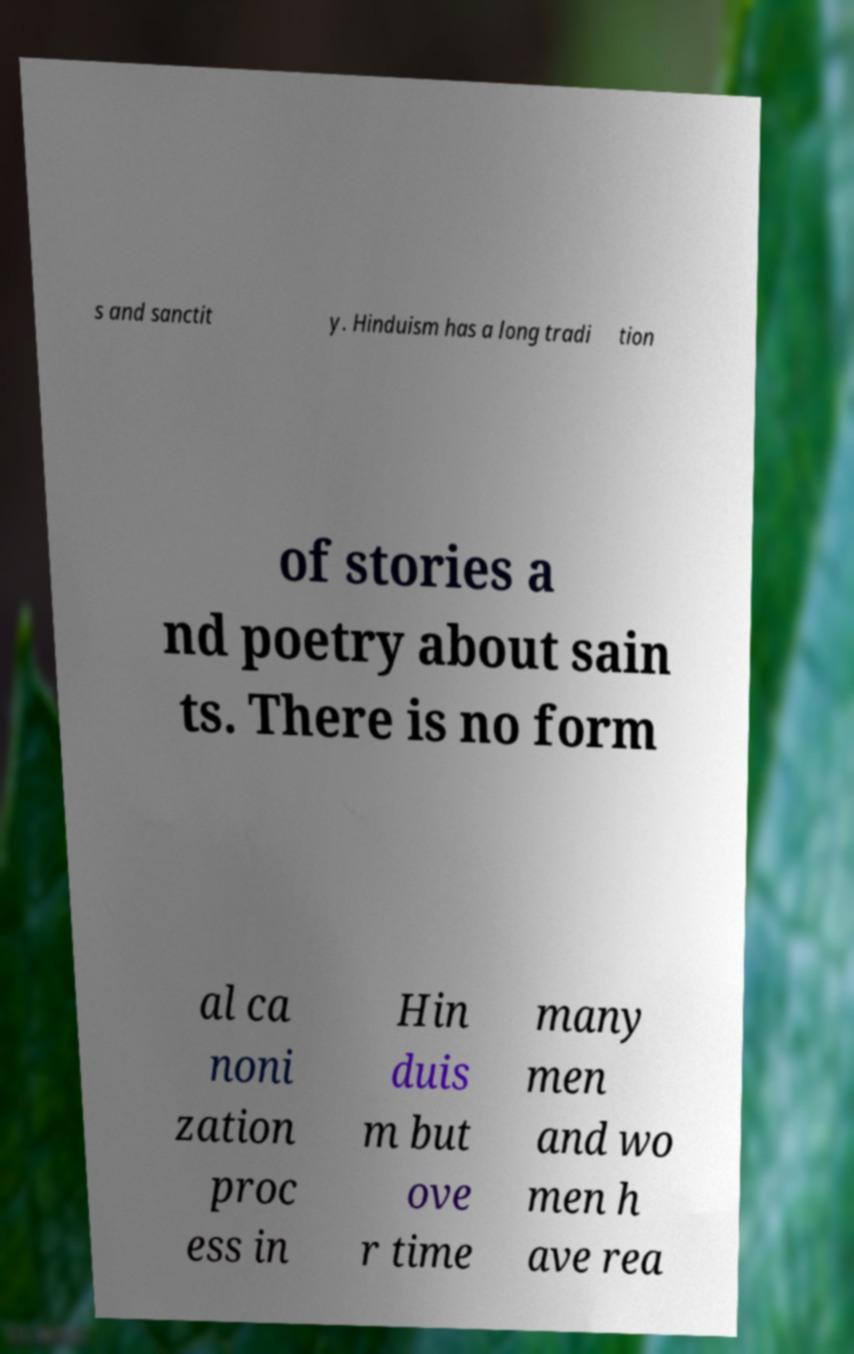For documentation purposes, I need the text within this image transcribed. Could you provide that? s and sanctit y. Hinduism has a long tradi tion of stories a nd poetry about sain ts. There is no form al ca noni zation proc ess in Hin duis m but ove r time many men and wo men h ave rea 